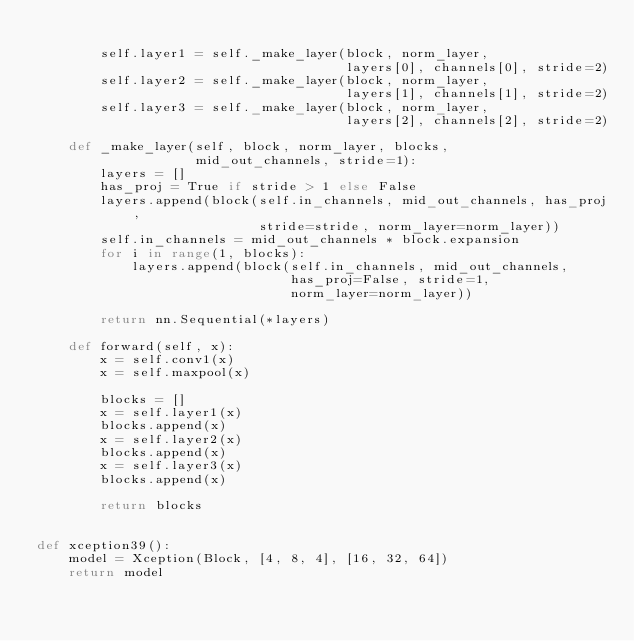<code> <loc_0><loc_0><loc_500><loc_500><_Python_>
        self.layer1 = self._make_layer(block, norm_layer,
                                       layers[0], channels[0], stride=2)
        self.layer2 = self._make_layer(block, norm_layer,
                                       layers[1], channels[1], stride=2)
        self.layer3 = self._make_layer(block, norm_layer,
                                       layers[2], channels[2], stride=2)

    def _make_layer(self, block, norm_layer, blocks,
                    mid_out_channels, stride=1):
        layers = []
        has_proj = True if stride > 1 else False
        layers.append(block(self.in_channels, mid_out_channels, has_proj,
                            stride=stride, norm_layer=norm_layer))
        self.in_channels = mid_out_channels * block.expansion
        for i in range(1, blocks):
            layers.append(block(self.in_channels, mid_out_channels,
                                has_proj=False, stride=1,
                                norm_layer=norm_layer))

        return nn.Sequential(*layers)

    def forward(self, x):
        x = self.conv1(x)
        x = self.maxpool(x)

        blocks = []
        x = self.layer1(x)
        blocks.append(x)
        x = self.layer2(x)
        blocks.append(x)
        x = self.layer3(x)
        blocks.append(x)

        return blocks


def xception39():
    model = Xception(Block, [4, 8, 4], [16, 32, 64])
    return model</code> 